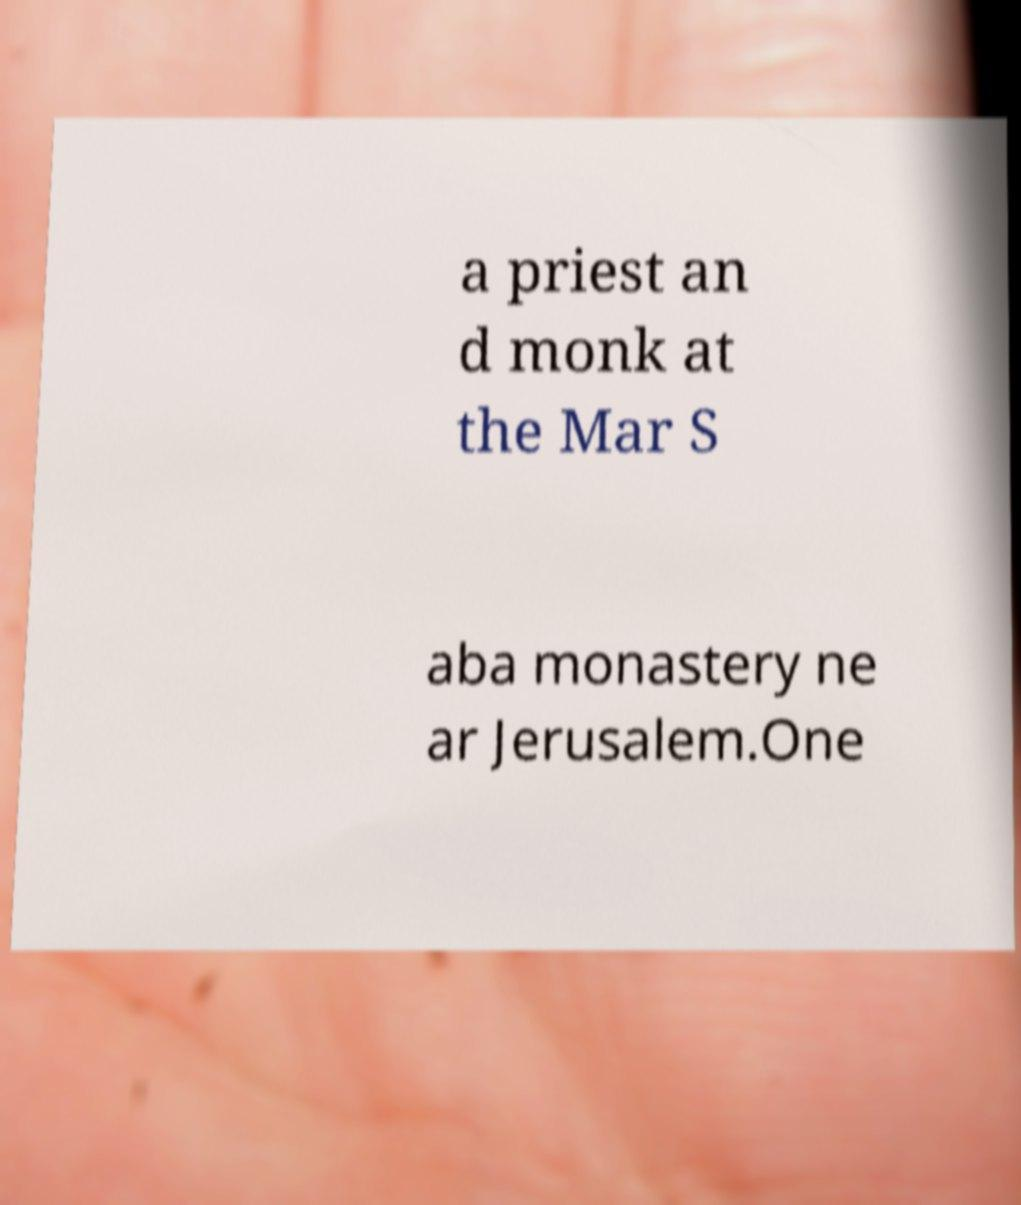Can you read and provide the text displayed in the image?This photo seems to have some interesting text. Can you extract and type it out for me? a priest an d monk at the Mar S aba monastery ne ar Jerusalem.One 